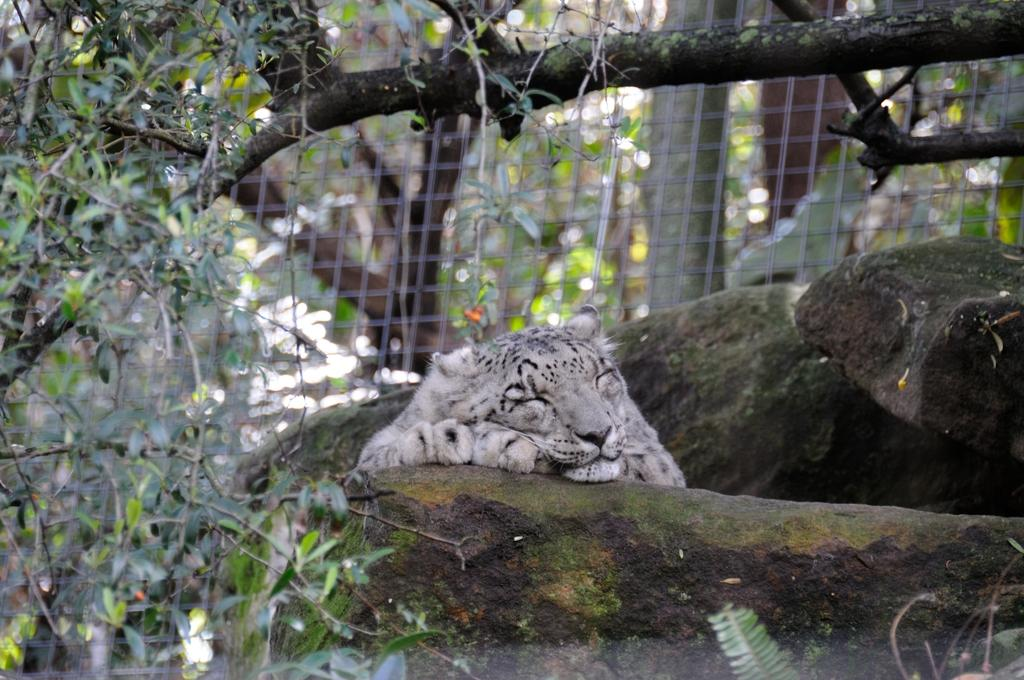What type of animal is in the image? There is a tiger in the image. What is the tiger doing in the image? The tiger is sleeping. What type of natural environment is visible in the image? There are trees in the image. What other object can be seen in the image? There is a rock in the image. What type of cheese is the tiger eating in the image? There is no cheese present in the image; the tiger is sleeping. What type of chain is the tiger wearing around its neck in the image? There is no chain present in the image; the tiger is not wearing any accessories. 